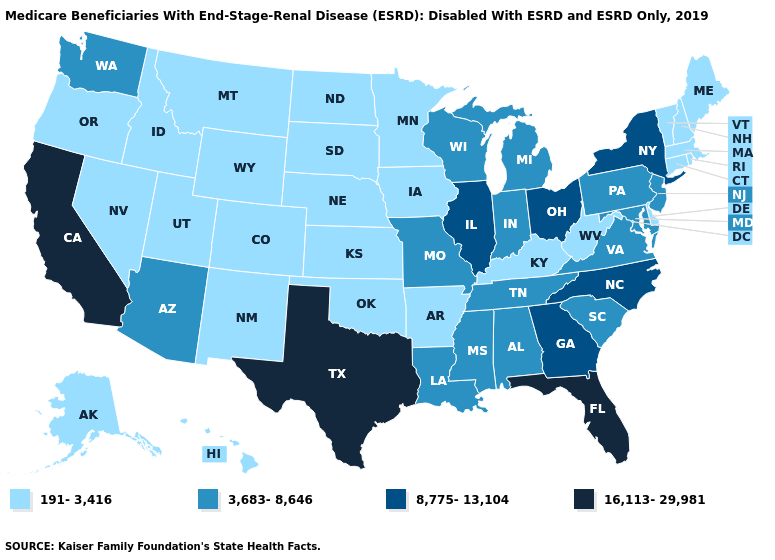Name the states that have a value in the range 16,113-29,981?
Be succinct. California, Florida, Texas. Does West Virginia have a lower value than New Hampshire?
Be succinct. No. Does Idaho have the same value as New Mexico?
Short answer required. Yes. Name the states that have a value in the range 8,775-13,104?
Keep it brief. Georgia, Illinois, New York, North Carolina, Ohio. Does the map have missing data?
Answer briefly. No. Does Vermont have the lowest value in the Northeast?
Keep it brief. Yes. What is the value of Rhode Island?
Concise answer only. 191-3,416. What is the value of Nevada?
Concise answer only. 191-3,416. Does Louisiana have the same value as Alaska?
Be succinct. No. Name the states that have a value in the range 16,113-29,981?
Answer briefly. California, Florida, Texas. What is the value of Connecticut?
Short answer required. 191-3,416. What is the value of Indiana?
Quick response, please. 3,683-8,646. Name the states that have a value in the range 16,113-29,981?
Quick response, please. California, Florida, Texas. Does Alaska have the same value as Indiana?
Give a very brief answer. No. What is the lowest value in the USA?
Short answer required. 191-3,416. 